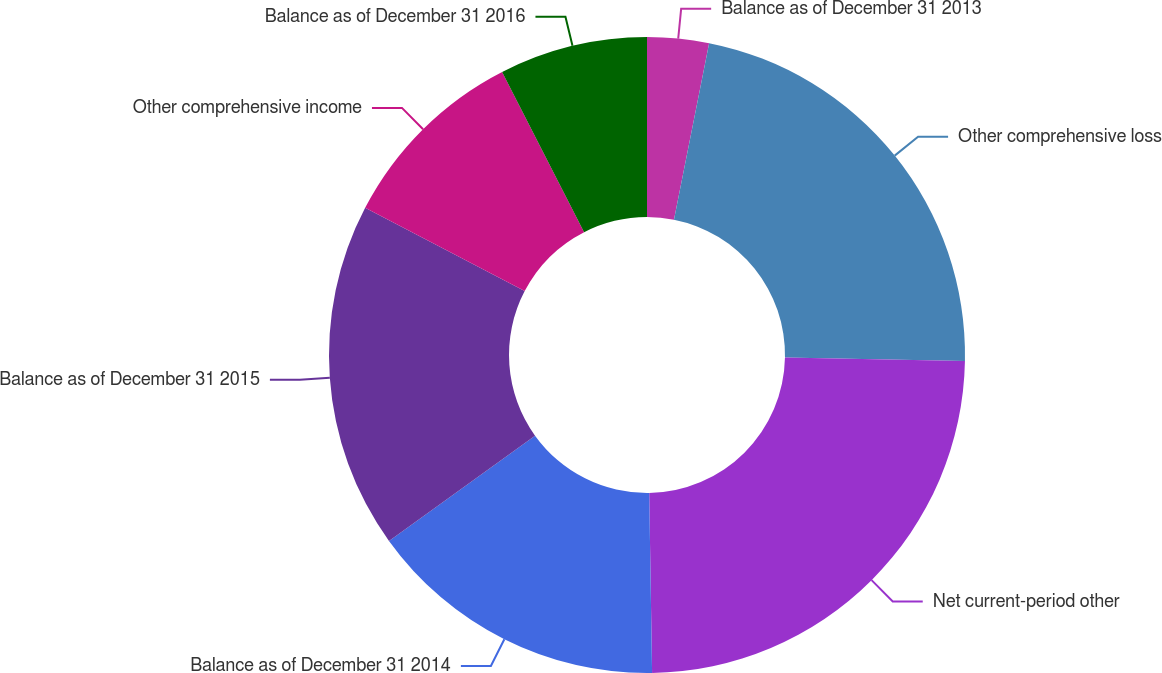Convert chart to OTSL. <chart><loc_0><loc_0><loc_500><loc_500><pie_chart><fcel>Balance as of December 31 2013<fcel>Other comprehensive loss<fcel>Net current-period other<fcel>Balance as of December 31 2014<fcel>Balance as of December 31 2015<fcel>Other comprehensive income<fcel>Balance as of December 31 2016<nl><fcel>3.13%<fcel>22.17%<fcel>24.45%<fcel>15.32%<fcel>17.6%<fcel>9.81%<fcel>7.53%<nl></chart> 